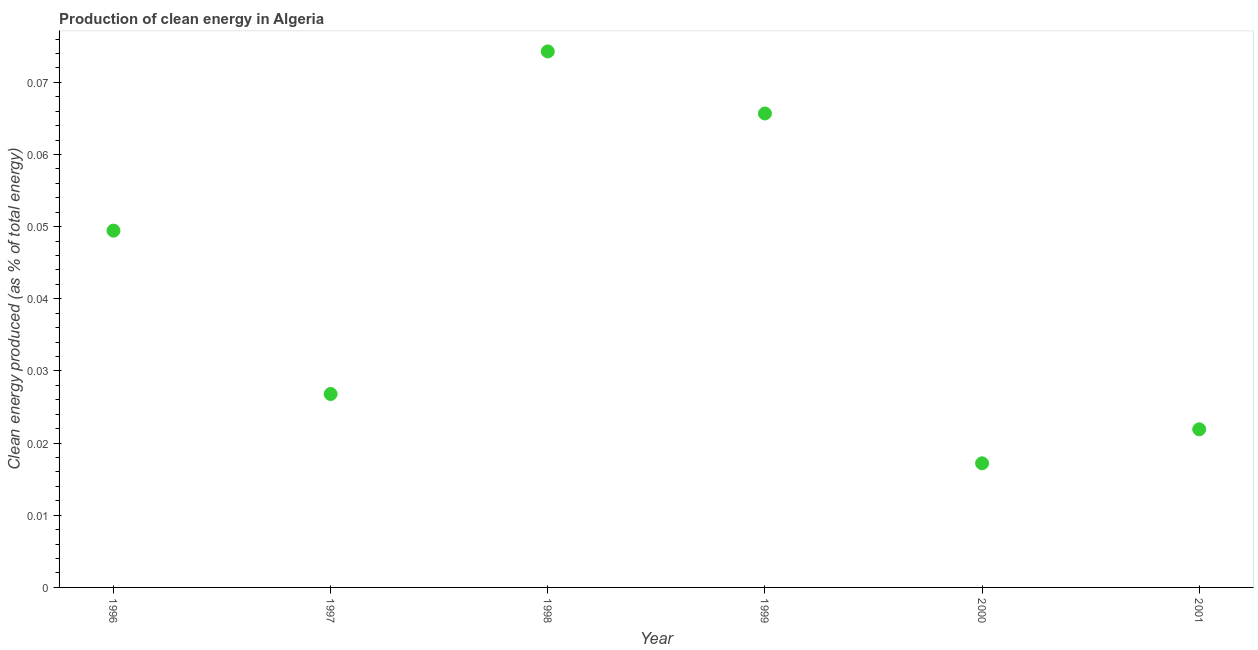What is the production of clean energy in 1997?
Your response must be concise. 0.03. Across all years, what is the maximum production of clean energy?
Your answer should be compact. 0.07. Across all years, what is the minimum production of clean energy?
Your response must be concise. 0.02. In which year was the production of clean energy maximum?
Ensure brevity in your answer.  1998. In which year was the production of clean energy minimum?
Offer a terse response. 2000. What is the sum of the production of clean energy?
Ensure brevity in your answer.  0.26. What is the difference between the production of clean energy in 1998 and 2000?
Offer a very short reply. 0.06. What is the average production of clean energy per year?
Your answer should be very brief. 0.04. What is the median production of clean energy?
Offer a very short reply. 0.04. In how many years, is the production of clean energy greater than 0.062 %?
Keep it short and to the point. 2. Do a majority of the years between 1999 and 1997 (inclusive) have production of clean energy greater than 0.004 %?
Offer a terse response. No. What is the ratio of the production of clean energy in 1998 to that in 1999?
Your answer should be very brief. 1.13. Is the difference between the production of clean energy in 1997 and 2000 greater than the difference between any two years?
Offer a very short reply. No. What is the difference between the highest and the second highest production of clean energy?
Offer a very short reply. 0.01. What is the difference between the highest and the lowest production of clean energy?
Make the answer very short. 0.06. Does the production of clean energy monotonically increase over the years?
Your response must be concise. No. How many dotlines are there?
Ensure brevity in your answer.  1. How many years are there in the graph?
Provide a short and direct response. 6. What is the difference between two consecutive major ticks on the Y-axis?
Your response must be concise. 0.01. Are the values on the major ticks of Y-axis written in scientific E-notation?
Your response must be concise. No. Does the graph contain grids?
Keep it short and to the point. No. What is the title of the graph?
Make the answer very short. Production of clean energy in Algeria. What is the label or title of the X-axis?
Give a very brief answer. Year. What is the label or title of the Y-axis?
Offer a very short reply. Clean energy produced (as % of total energy). What is the Clean energy produced (as % of total energy) in 1996?
Provide a succinct answer. 0.05. What is the Clean energy produced (as % of total energy) in 1997?
Offer a very short reply. 0.03. What is the Clean energy produced (as % of total energy) in 1998?
Offer a very short reply. 0.07. What is the Clean energy produced (as % of total energy) in 1999?
Offer a very short reply. 0.07. What is the Clean energy produced (as % of total energy) in 2000?
Give a very brief answer. 0.02. What is the Clean energy produced (as % of total energy) in 2001?
Make the answer very short. 0.02. What is the difference between the Clean energy produced (as % of total energy) in 1996 and 1997?
Provide a succinct answer. 0.02. What is the difference between the Clean energy produced (as % of total energy) in 1996 and 1998?
Your response must be concise. -0.02. What is the difference between the Clean energy produced (as % of total energy) in 1996 and 1999?
Provide a short and direct response. -0.02. What is the difference between the Clean energy produced (as % of total energy) in 1996 and 2000?
Offer a terse response. 0.03. What is the difference between the Clean energy produced (as % of total energy) in 1996 and 2001?
Offer a very short reply. 0.03. What is the difference between the Clean energy produced (as % of total energy) in 1997 and 1998?
Keep it short and to the point. -0.05. What is the difference between the Clean energy produced (as % of total energy) in 1997 and 1999?
Provide a succinct answer. -0.04. What is the difference between the Clean energy produced (as % of total energy) in 1997 and 2000?
Your response must be concise. 0.01. What is the difference between the Clean energy produced (as % of total energy) in 1997 and 2001?
Your answer should be very brief. 0. What is the difference between the Clean energy produced (as % of total energy) in 1998 and 1999?
Make the answer very short. 0.01. What is the difference between the Clean energy produced (as % of total energy) in 1998 and 2000?
Provide a succinct answer. 0.06. What is the difference between the Clean energy produced (as % of total energy) in 1998 and 2001?
Your response must be concise. 0.05. What is the difference between the Clean energy produced (as % of total energy) in 1999 and 2000?
Ensure brevity in your answer.  0.05. What is the difference between the Clean energy produced (as % of total energy) in 1999 and 2001?
Offer a terse response. 0.04. What is the difference between the Clean energy produced (as % of total energy) in 2000 and 2001?
Keep it short and to the point. -0. What is the ratio of the Clean energy produced (as % of total energy) in 1996 to that in 1997?
Give a very brief answer. 1.84. What is the ratio of the Clean energy produced (as % of total energy) in 1996 to that in 1998?
Your answer should be very brief. 0.67. What is the ratio of the Clean energy produced (as % of total energy) in 1996 to that in 1999?
Your answer should be compact. 0.75. What is the ratio of the Clean energy produced (as % of total energy) in 1996 to that in 2000?
Offer a terse response. 2.88. What is the ratio of the Clean energy produced (as % of total energy) in 1996 to that in 2001?
Keep it short and to the point. 2.26. What is the ratio of the Clean energy produced (as % of total energy) in 1997 to that in 1998?
Offer a very short reply. 0.36. What is the ratio of the Clean energy produced (as % of total energy) in 1997 to that in 1999?
Keep it short and to the point. 0.41. What is the ratio of the Clean energy produced (as % of total energy) in 1997 to that in 2000?
Offer a terse response. 1.56. What is the ratio of the Clean energy produced (as % of total energy) in 1997 to that in 2001?
Ensure brevity in your answer.  1.22. What is the ratio of the Clean energy produced (as % of total energy) in 1998 to that in 1999?
Ensure brevity in your answer.  1.13. What is the ratio of the Clean energy produced (as % of total energy) in 1998 to that in 2000?
Offer a very short reply. 4.32. What is the ratio of the Clean energy produced (as % of total energy) in 1998 to that in 2001?
Provide a succinct answer. 3.39. What is the ratio of the Clean energy produced (as % of total energy) in 1999 to that in 2000?
Your answer should be very brief. 3.82. What is the ratio of the Clean energy produced (as % of total energy) in 1999 to that in 2001?
Provide a succinct answer. 3. What is the ratio of the Clean energy produced (as % of total energy) in 2000 to that in 2001?
Your answer should be compact. 0.79. 